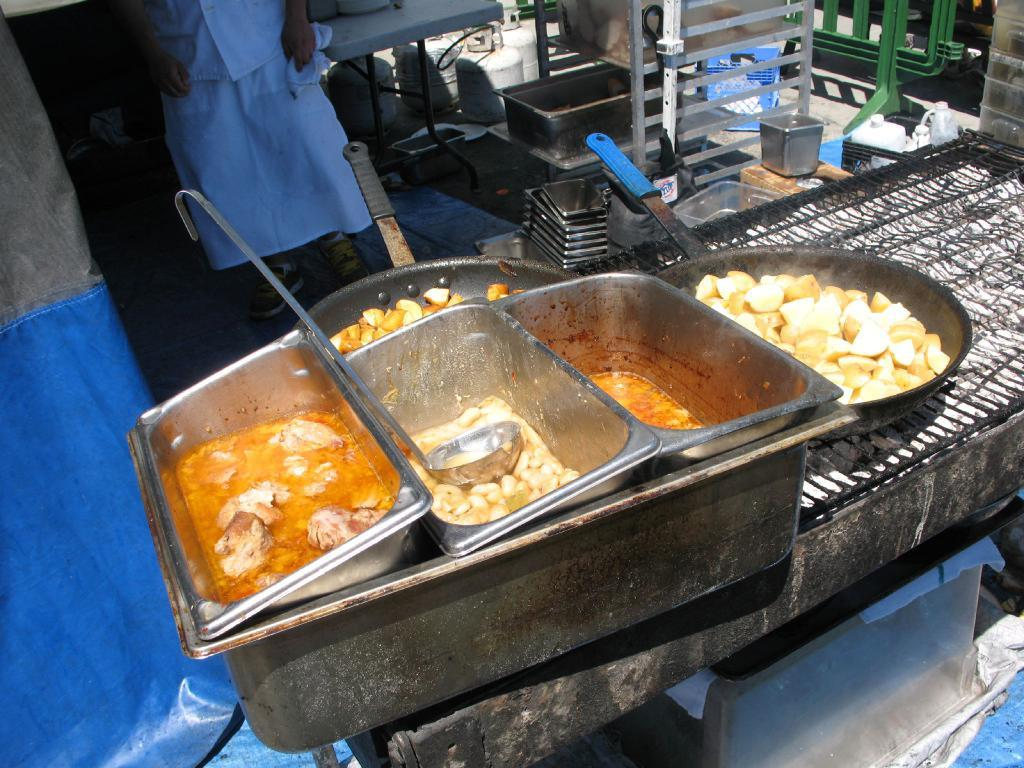What is the main object in the image? There is a grill in the image. What is placed on the grill? There are pans and vessels on the grill. Are there any other items on the grill? Yes, there are other unspecified things on the grill. Who is present near the grill? There is a person next to the grill. What is the value of the vacation that the dinosaurs are planning in the image? There are no dinosaurs or vacation mentioned in the image; it only features a grill with pans, vessels, and other unspecified items, along with a person nearby. 